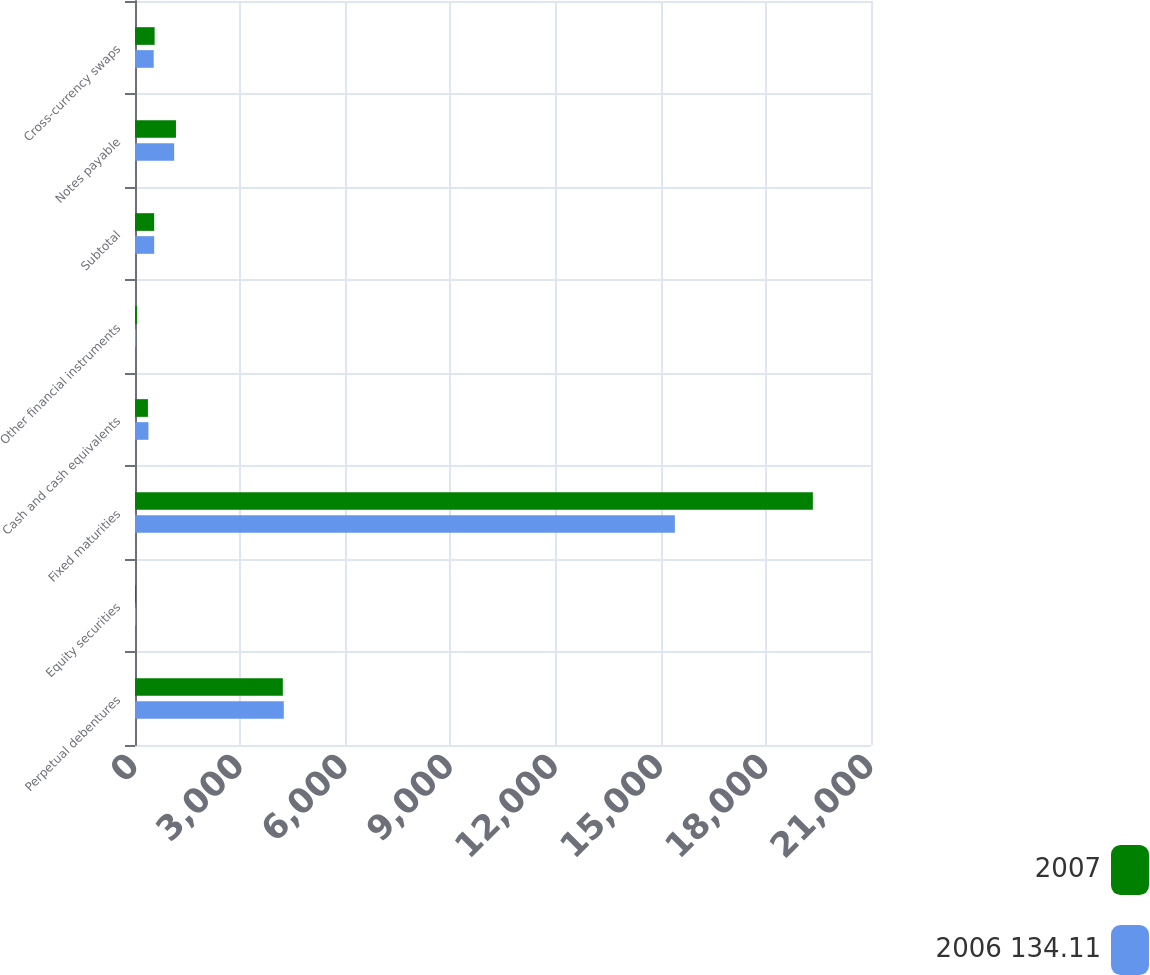<chart> <loc_0><loc_0><loc_500><loc_500><stacked_bar_chart><ecel><fcel>Perpetual debentures<fcel>Equity securities<fcel>Fixed maturities<fcel>Cash and cash equivalents<fcel>Other financial instruments<fcel>Subtotal<fcel>Notes payable<fcel>Cross-currency swaps<nl><fcel>2007<fcel>4218<fcel>25<fcel>19341<fcel>369<fcel>60<fcel>547<fcel>1169<fcel>560<nl><fcel>2006 134.11<fcel>4246<fcel>29<fcel>15404<fcel>383<fcel>32<fcel>547<fcel>1117<fcel>534<nl></chart> 